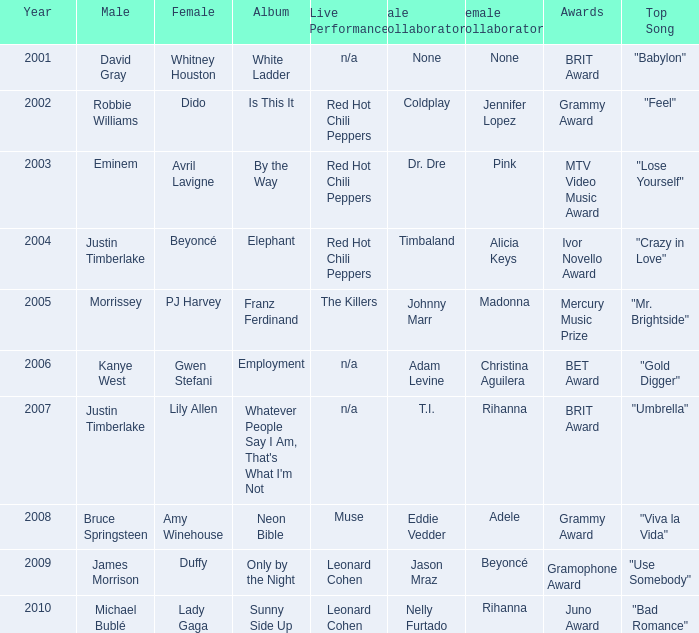Which male is paired with dido in 2004? Robbie Williams. 